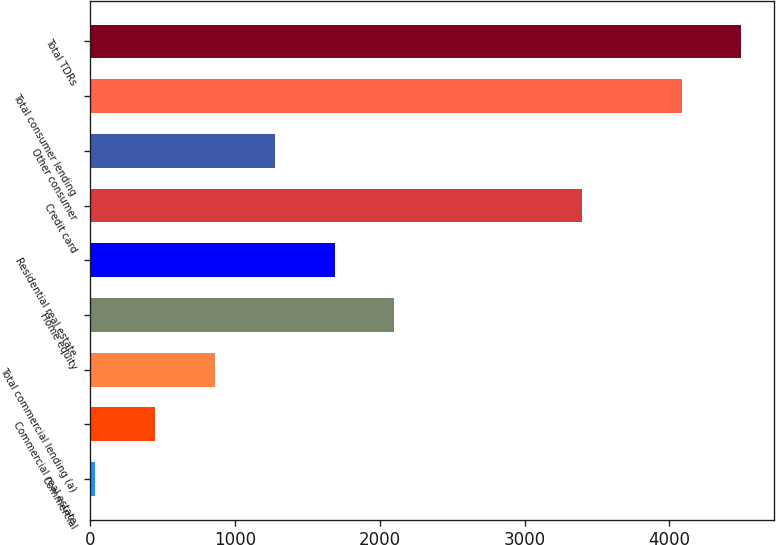Convert chart. <chart><loc_0><loc_0><loc_500><loc_500><bar_chart><fcel>Commercial<fcel>Commercial real estate<fcel>Total commercial lending (a)<fcel>Home equity<fcel>Residential real estate<fcel>Credit card<fcel>Other consumer<fcel>Total consumer lending<fcel>Total TDRs<nl><fcel>38<fcel>450.7<fcel>863.4<fcel>2101.5<fcel>1688.8<fcel>3397<fcel>1276.1<fcel>4084<fcel>4496.7<nl></chart> 